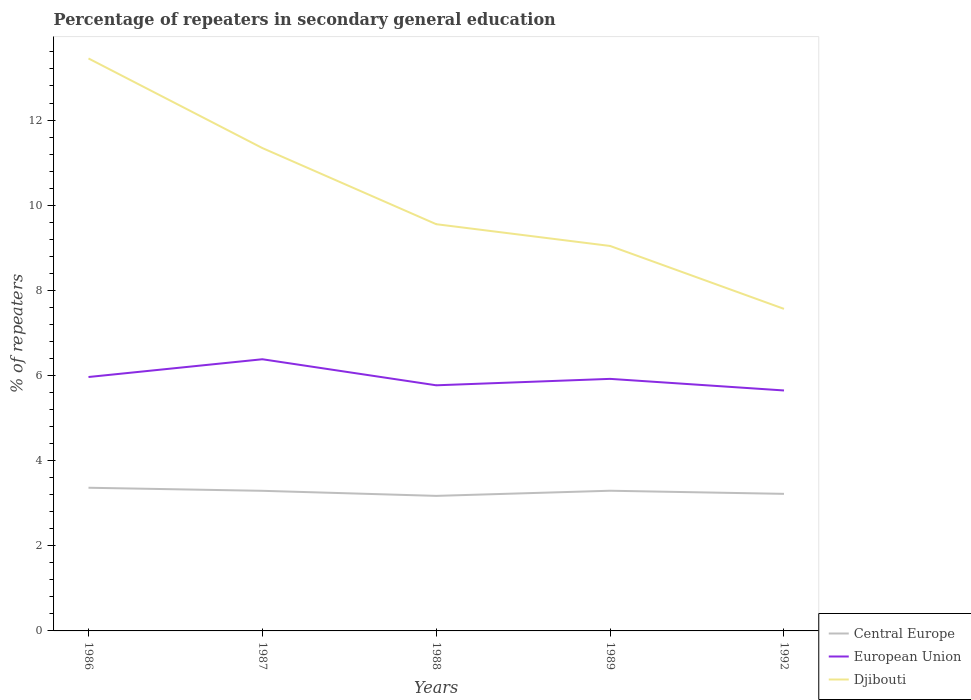How many different coloured lines are there?
Offer a terse response. 3. Across all years, what is the maximum percentage of repeaters in secondary general education in Central Europe?
Keep it short and to the point. 3.17. What is the total percentage of repeaters in secondary general education in Djibouti in the graph?
Offer a terse response. 3.78. What is the difference between the highest and the second highest percentage of repeaters in secondary general education in European Union?
Provide a short and direct response. 0.73. What is the difference between the highest and the lowest percentage of repeaters in secondary general education in European Union?
Keep it short and to the point. 2. Does the graph contain any zero values?
Provide a short and direct response. No. Does the graph contain grids?
Offer a very short reply. No. Where does the legend appear in the graph?
Offer a very short reply. Bottom right. What is the title of the graph?
Ensure brevity in your answer.  Percentage of repeaters in secondary general education. Does "Sub-Saharan Africa (all income levels)" appear as one of the legend labels in the graph?
Ensure brevity in your answer.  No. What is the label or title of the Y-axis?
Offer a very short reply. % of repeaters. What is the % of repeaters of Central Europe in 1986?
Give a very brief answer. 3.36. What is the % of repeaters in European Union in 1986?
Your response must be concise. 5.96. What is the % of repeaters of Djibouti in 1986?
Offer a very short reply. 13.45. What is the % of repeaters of Central Europe in 1987?
Keep it short and to the point. 3.29. What is the % of repeaters in European Union in 1987?
Offer a terse response. 6.38. What is the % of repeaters in Djibouti in 1987?
Make the answer very short. 11.34. What is the % of repeaters in Central Europe in 1988?
Keep it short and to the point. 3.17. What is the % of repeaters of European Union in 1988?
Your answer should be very brief. 5.77. What is the % of repeaters in Djibouti in 1988?
Your answer should be compact. 9.55. What is the % of repeaters of Central Europe in 1989?
Provide a succinct answer. 3.29. What is the % of repeaters of European Union in 1989?
Your answer should be very brief. 5.92. What is the % of repeaters of Djibouti in 1989?
Your answer should be very brief. 9.04. What is the % of repeaters in Central Europe in 1992?
Your response must be concise. 3.22. What is the % of repeaters of European Union in 1992?
Ensure brevity in your answer.  5.65. What is the % of repeaters in Djibouti in 1992?
Make the answer very short. 7.56. Across all years, what is the maximum % of repeaters in Central Europe?
Your answer should be compact. 3.36. Across all years, what is the maximum % of repeaters in European Union?
Your answer should be compact. 6.38. Across all years, what is the maximum % of repeaters in Djibouti?
Your answer should be compact. 13.45. Across all years, what is the minimum % of repeaters in Central Europe?
Provide a succinct answer. 3.17. Across all years, what is the minimum % of repeaters of European Union?
Offer a terse response. 5.65. Across all years, what is the minimum % of repeaters of Djibouti?
Keep it short and to the point. 7.56. What is the total % of repeaters in Central Europe in the graph?
Make the answer very short. 16.34. What is the total % of repeaters in European Union in the graph?
Keep it short and to the point. 29.68. What is the total % of repeaters of Djibouti in the graph?
Provide a short and direct response. 50.95. What is the difference between the % of repeaters of Central Europe in 1986 and that in 1987?
Give a very brief answer. 0.07. What is the difference between the % of repeaters in European Union in 1986 and that in 1987?
Ensure brevity in your answer.  -0.42. What is the difference between the % of repeaters in Djibouti in 1986 and that in 1987?
Provide a short and direct response. 2.1. What is the difference between the % of repeaters in Central Europe in 1986 and that in 1988?
Make the answer very short. 0.19. What is the difference between the % of repeaters of European Union in 1986 and that in 1988?
Offer a very short reply. 0.19. What is the difference between the % of repeaters of Djibouti in 1986 and that in 1988?
Your response must be concise. 3.89. What is the difference between the % of repeaters in Central Europe in 1986 and that in 1989?
Your answer should be compact. 0.07. What is the difference between the % of repeaters in European Union in 1986 and that in 1989?
Give a very brief answer. 0.04. What is the difference between the % of repeaters in Djibouti in 1986 and that in 1989?
Your answer should be compact. 4.4. What is the difference between the % of repeaters of Central Europe in 1986 and that in 1992?
Ensure brevity in your answer.  0.14. What is the difference between the % of repeaters in European Union in 1986 and that in 1992?
Your answer should be compact. 0.32. What is the difference between the % of repeaters in Djibouti in 1986 and that in 1992?
Ensure brevity in your answer.  5.88. What is the difference between the % of repeaters of Central Europe in 1987 and that in 1988?
Ensure brevity in your answer.  0.12. What is the difference between the % of repeaters in European Union in 1987 and that in 1988?
Offer a terse response. 0.61. What is the difference between the % of repeaters of Djibouti in 1987 and that in 1988?
Your response must be concise. 1.79. What is the difference between the % of repeaters of Central Europe in 1987 and that in 1989?
Offer a terse response. -0. What is the difference between the % of repeaters of European Union in 1987 and that in 1989?
Provide a succinct answer. 0.46. What is the difference between the % of repeaters of Djibouti in 1987 and that in 1989?
Your answer should be compact. 2.3. What is the difference between the % of repeaters of Central Europe in 1987 and that in 1992?
Give a very brief answer. 0.07. What is the difference between the % of repeaters of European Union in 1987 and that in 1992?
Provide a short and direct response. 0.73. What is the difference between the % of repeaters in Djibouti in 1987 and that in 1992?
Make the answer very short. 3.78. What is the difference between the % of repeaters of Central Europe in 1988 and that in 1989?
Your answer should be compact. -0.12. What is the difference between the % of repeaters in European Union in 1988 and that in 1989?
Make the answer very short. -0.15. What is the difference between the % of repeaters of Djibouti in 1988 and that in 1989?
Ensure brevity in your answer.  0.51. What is the difference between the % of repeaters in Central Europe in 1988 and that in 1992?
Keep it short and to the point. -0.05. What is the difference between the % of repeaters of European Union in 1988 and that in 1992?
Your answer should be compact. 0.12. What is the difference between the % of repeaters in Djibouti in 1988 and that in 1992?
Your answer should be very brief. 1.99. What is the difference between the % of repeaters in Central Europe in 1989 and that in 1992?
Your answer should be compact. 0.07. What is the difference between the % of repeaters in European Union in 1989 and that in 1992?
Provide a short and direct response. 0.27. What is the difference between the % of repeaters of Djibouti in 1989 and that in 1992?
Provide a short and direct response. 1.48. What is the difference between the % of repeaters of Central Europe in 1986 and the % of repeaters of European Union in 1987?
Your response must be concise. -3.02. What is the difference between the % of repeaters in Central Europe in 1986 and the % of repeaters in Djibouti in 1987?
Ensure brevity in your answer.  -7.98. What is the difference between the % of repeaters of European Union in 1986 and the % of repeaters of Djibouti in 1987?
Your response must be concise. -5.38. What is the difference between the % of repeaters in Central Europe in 1986 and the % of repeaters in European Union in 1988?
Your answer should be compact. -2.41. What is the difference between the % of repeaters in Central Europe in 1986 and the % of repeaters in Djibouti in 1988?
Your response must be concise. -6.19. What is the difference between the % of repeaters in European Union in 1986 and the % of repeaters in Djibouti in 1988?
Offer a terse response. -3.59. What is the difference between the % of repeaters in Central Europe in 1986 and the % of repeaters in European Union in 1989?
Keep it short and to the point. -2.56. What is the difference between the % of repeaters in Central Europe in 1986 and the % of repeaters in Djibouti in 1989?
Give a very brief answer. -5.68. What is the difference between the % of repeaters in European Union in 1986 and the % of repeaters in Djibouti in 1989?
Provide a succinct answer. -3.08. What is the difference between the % of repeaters of Central Europe in 1986 and the % of repeaters of European Union in 1992?
Your answer should be compact. -2.29. What is the difference between the % of repeaters in Central Europe in 1986 and the % of repeaters in Djibouti in 1992?
Provide a succinct answer. -4.2. What is the difference between the % of repeaters in European Union in 1986 and the % of repeaters in Djibouti in 1992?
Provide a succinct answer. -1.6. What is the difference between the % of repeaters in Central Europe in 1987 and the % of repeaters in European Union in 1988?
Provide a succinct answer. -2.48. What is the difference between the % of repeaters in Central Europe in 1987 and the % of repeaters in Djibouti in 1988?
Your answer should be very brief. -6.26. What is the difference between the % of repeaters of European Union in 1987 and the % of repeaters of Djibouti in 1988?
Provide a short and direct response. -3.17. What is the difference between the % of repeaters of Central Europe in 1987 and the % of repeaters of European Union in 1989?
Your response must be concise. -2.63. What is the difference between the % of repeaters of Central Europe in 1987 and the % of repeaters of Djibouti in 1989?
Provide a short and direct response. -5.75. What is the difference between the % of repeaters of European Union in 1987 and the % of repeaters of Djibouti in 1989?
Your answer should be compact. -2.66. What is the difference between the % of repeaters in Central Europe in 1987 and the % of repeaters in European Union in 1992?
Give a very brief answer. -2.36. What is the difference between the % of repeaters in Central Europe in 1987 and the % of repeaters in Djibouti in 1992?
Keep it short and to the point. -4.27. What is the difference between the % of repeaters of European Union in 1987 and the % of repeaters of Djibouti in 1992?
Your response must be concise. -1.18. What is the difference between the % of repeaters of Central Europe in 1988 and the % of repeaters of European Union in 1989?
Your response must be concise. -2.75. What is the difference between the % of repeaters of Central Europe in 1988 and the % of repeaters of Djibouti in 1989?
Offer a very short reply. -5.87. What is the difference between the % of repeaters in European Union in 1988 and the % of repeaters in Djibouti in 1989?
Keep it short and to the point. -3.27. What is the difference between the % of repeaters in Central Europe in 1988 and the % of repeaters in European Union in 1992?
Keep it short and to the point. -2.48. What is the difference between the % of repeaters in Central Europe in 1988 and the % of repeaters in Djibouti in 1992?
Provide a short and direct response. -4.39. What is the difference between the % of repeaters of European Union in 1988 and the % of repeaters of Djibouti in 1992?
Ensure brevity in your answer.  -1.8. What is the difference between the % of repeaters of Central Europe in 1989 and the % of repeaters of European Union in 1992?
Ensure brevity in your answer.  -2.35. What is the difference between the % of repeaters of Central Europe in 1989 and the % of repeaters of Djibouti in 1992?
Provide a succinct answer. -4.27. What is the difference between the % of repeaters in European Union in 1989 and the % of repeaters in Djibouti in 1992?
Ensure brevity in your answer.  -1.64. What is the average % of repeaters in Central Europe per year?
Make the answer very short. 3.27. What is the average % of repeaters of European Union per year?
Ensure brevity in your answer.  5.94. What is the average % of repeaters of Djibouti per year?
Make the answer very short. 10.19. In the year 1986, what is the difference between the % of repeaters of Central Europe and % of repeaters of European Union?
Ensure brevity in your answer.  -2.6. In the year 1986, what is the difference between the % of repeaters of Central Europe and % of repeaters of Djibouti?
Keep it short and to the point. -10.08. In the year 1986, what is the difference between the % of repeaters in European Union and % of repeaters in Djibouti?
Provide a succinct answer. -7.48. In the year 1987, what is the difference between the % of repeaters of Central Europe and % of repeaters of European Union?
Offer a terse response. -3.09. In the year 1987, what is the difference between the % of repeaters in Central Europe and % of repeaters in Djibouti?
Offer a very short reply. -8.05. In the year 1987, what is the difference between the % of repeaters of European Union and % of repeaters of Djibouti?
Your answer should be very brief. -4.96. In the year 1988, what is the difference between the % of repeaters in Central Europe and % of repeaters in European Union?
Offer a terse response. -2.6. In the year 1988, what is the difference between the % of repeaters in Central Europe and % of repeaters in Djibouti?
Offer a terse response. -6.38. In the year 1988, what is the difference between the % of repeaters in European Union and % of repeaters in Djibouti?
Provide a short and direct response. -3.78. In the year 1989, what is the difference between the % of repeaters in Central Europe and % of repeaters in European Union?
Offer a very short reply. -2.63. In the year 1989, what is the difference between the % of repeaters of Central Europe and % of repeaters of Djibouti?
Your answer should be very brief. -5.75. In the year 1989, what is the difference between the % of repeaters in European Union and % of repeaters in Djibouti?
Offer a terse response. -3.12. In the year 1992, what is the difference between the % of repeaters of Central Europe and % of repeaters of European Union?
Your answer should be compact. -2.43. In the year 1992, what is the difference between the % of repeaters of Central Europe and % of repeaters of Djibouti?
Provide a short and direct response. -4.35. In the year 1992, what is the difference between the % of repeaters in European Union and % of repeaters in Djibouti?
Ensure brevity in your answer.  -1.92. What is the ratio of the % of repeaters of Central Europe in 1986 to that in 1987?
Make the answer very short. 1.02. What is the ratio of the % of repeaters in European Union in 1986 to that in 1987?
Keep it short and to the point. 0.93. What is the ratio of the % of repeaters of Djibouti in 1986 to that in 1987?
Keep it short and to the point. 1.19. What is the ratio of the % of repeaters in Central Europe in 1986 to that in 1988?
Your answer should be compact. 1.06. What is the ratio of the % of repeaters of European Union in 1986 to that in 1988?
Keep it short and to the point. 1.03. What is the ratio of the % of repeaters in Djibouti in 1986 to that in 1988?
Your answer should be compact. 1.41. What is the ratio of the % of repeaters of Central Europe in 1986 to that in 1989?
Make the answer very short. 1.02. What is the ratio of the % of repeaters in European Union in 1986 to that in 1989?
Provide a short and direct response. 1.01. What is the ratio of the % of repeaters of Djibouti in 1986 to that in 1989?
Your response must be concise. 1.49. What is the ratio of the % of repeaters in Central Europe in 1986 to that in 1992?
Keep it short and to the point. 1.04. What is the ratio of the % of repeaters in European Union in 1986 to that in 1992?
Provide a succinct answer. 1.06. What is the ratio of the % of repeaters in Djibouti in 1986 to that in 1992?
Offer a very short reply. 1.78. What is the ratio of the % of repeaters of Central Europe in 1987 to that in 1988?
Your response must be concise. 1.04. What is the ratio of the % of repeaters of European Union in 1987 to that in 1988?
Your answer should be compact. 1.11. What is the ratio of the % of repeaters in Djibouti in 1987 to that in 1988?
Your answer should be very brief. 1.19. What is the ratio of the % of repeaters of European Union in 1987 to that in 1989?
Your response must be concise. 1.08. What is the ratio of the % of repeaters in Djibouti in 1987 to that in 1989?
Offer a terse response. 1.25. What is the ratio of the % of repeaters in Central Europe in 1987 to that in 1992?
Provide a succinct answer. 1.02. What is the ratio of the % of repeaters in European Union in 1987 to that in 1992?
Provide a short and direct response. 1.13. What is the ratio of the % of repeaters of Djibouti in 1987 to that in 1992?
Your answer should be compact. 1.5. What is the ratio of the % of repeaters in Central Europe in 1988 to that in 1989?
Offer a very short reply. 0.96. What is the ratio of the % of repeaters in European Union in 1988 to that in 1989?
Provide a succinct answer. 0.97. What is the ratio of the % of repeaters of Djibouti in 1988 to that in 1989?
Keep it short and to the point. 1.06. What is the ratio of the % of repeaters of Central Europe in 1988 to that in 1992?
Ensure brevity in your answer.  0.99. What is the ratio of the % of repeaters of European Union in 1988 to that in 1992?
Ensure brevity in your answer.  1.02. What is the ratio of the % of repeaters of Djibouti in 1988 to that in 1992?
Make the answer very short. 1.26. What is the ratio of the % of repeaters in Central Europe in 1989 to that in 1992?
Give a very brief answer. 1.02. What is the ratio of the % of repeaters of European Union in 1989 to that in 1992?
Ensure brevity in your answer.  1.05. What is the ratio of the % of repeaters in Djibouti in 1989 to that in 1992?
Ensure brevity in your answer.  1.2. What is the difference between the highest and the second highest % of repeaters in Central Europe?
Give a very brief answer. 0.07. What is the difference between the highest and the second highest % of repeaters in European Union?
Offer a very short reply. 0.42. What is the difference between the highest and the second highest % of repeaters of Djibouti?
Provide a succinct answer. 2.1. What is the difference between the highest and the lowest % of repeaters of Central Europe?
Provide a short and direct response. 0.19. What is the difference between the highest and the lowest % of repeaters of European Union?
Your answer should be compact. 0.73. What is the difference between the highest and the lowest % of repeaters of Djibouti?
Your answer should be very brief. 5.88. 